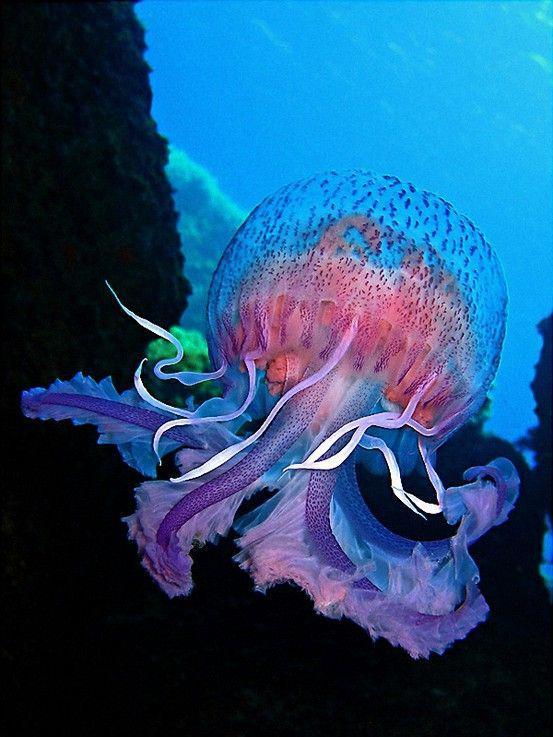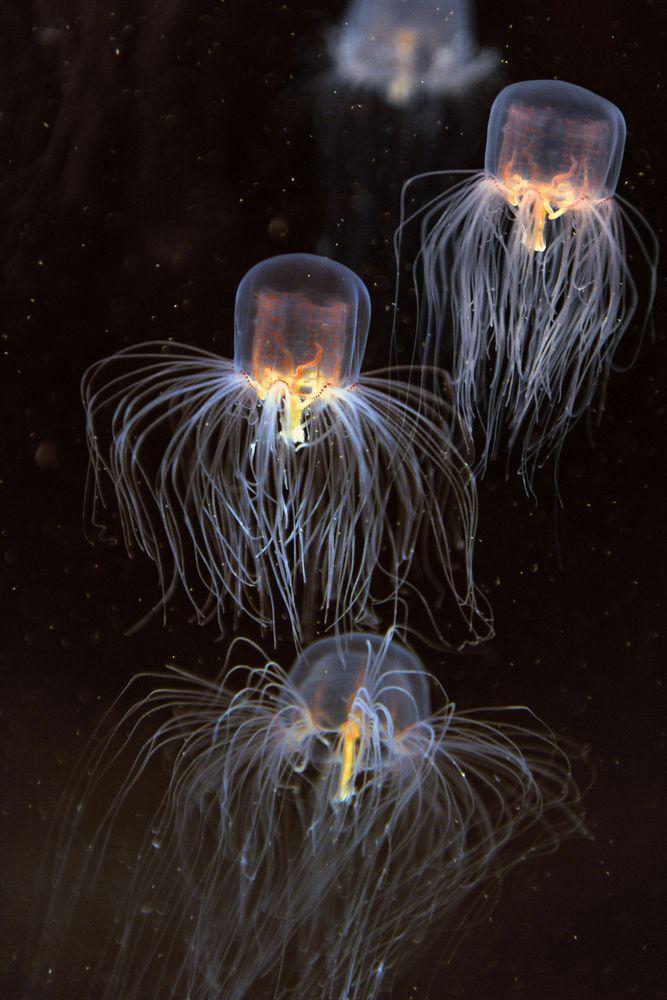The first image is the image on the left, the second image is the image on the right. Evaluate the accuracy of this statement regarding the images: "The jellyfish in the left and right images share the same shape 'caps' and are positioned with their tentacles facing the same direction.". Is it true? Answer yes or no. Yes. 